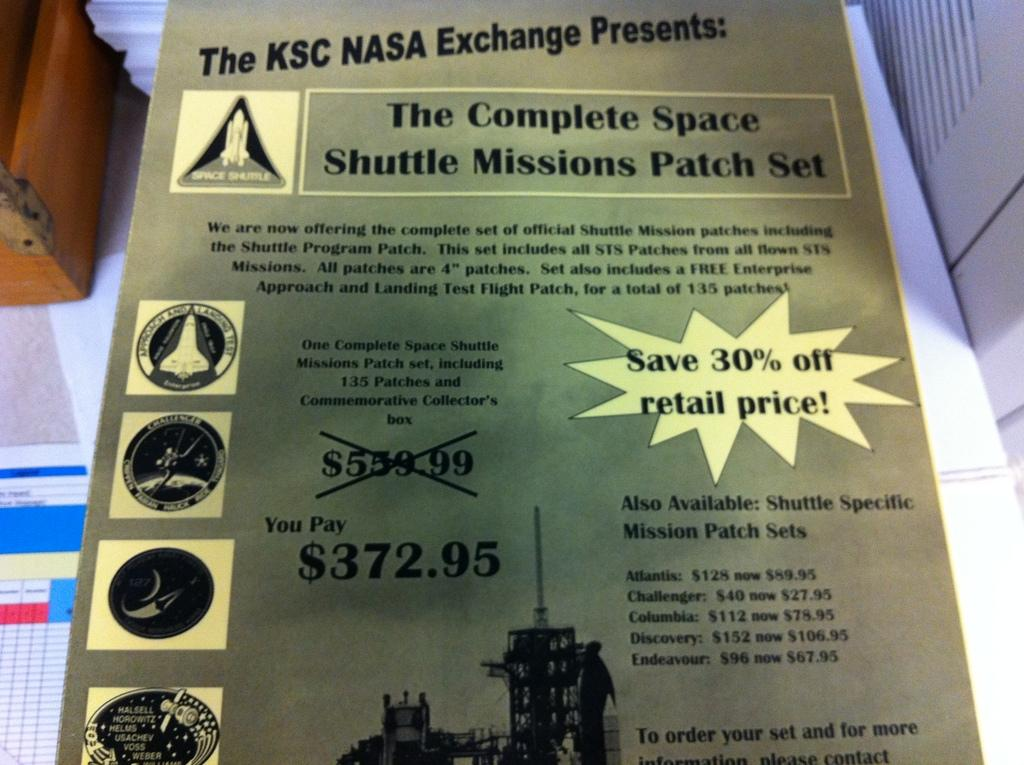<image>
Summarize the visual content of the image. a flyer about NASA EXCHANGE is laying on a table 